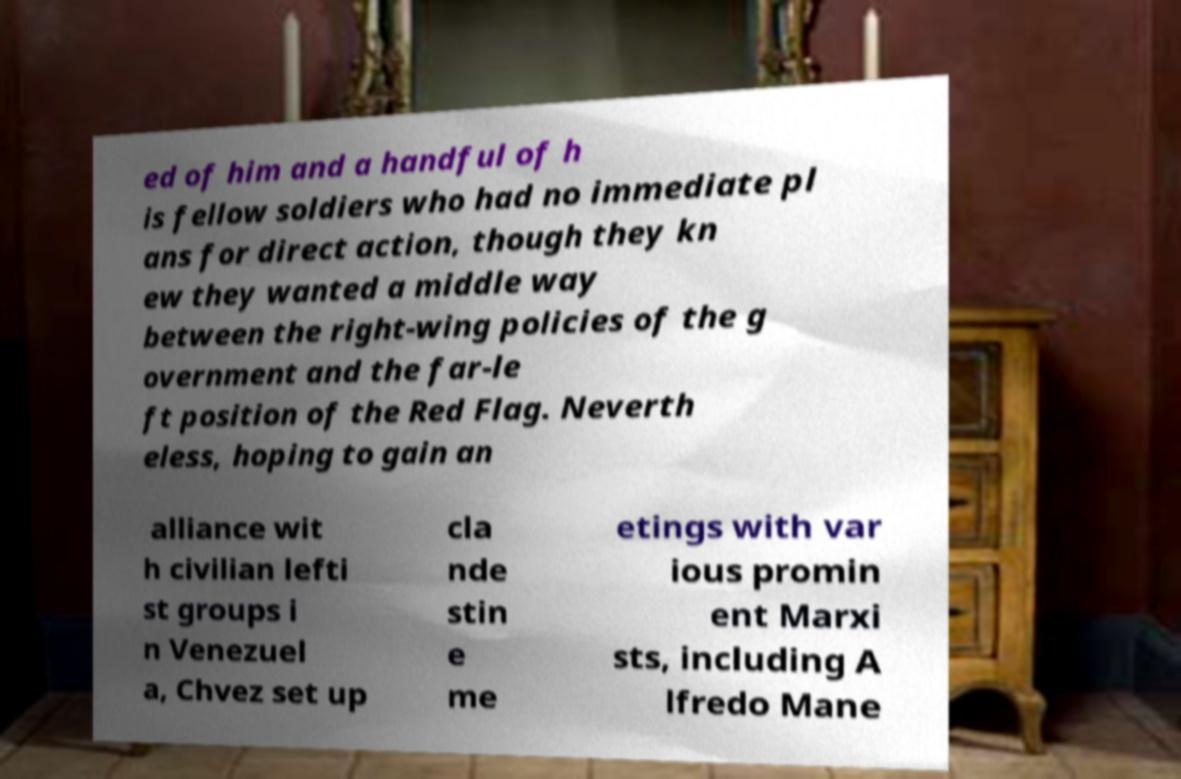What messages or text are displayed in this image? I need them in a readable, typed format. ed of him and a handful of h is fellow soldiers who had no immediate pl ans for direct action, though they kn ew they wanted a middle way between the right-wing policies of the g overnment and the far-le ft position of the Red Flag. Neverth eless, hoping to gain an alliance wit h civilian lefti st groups i n Venezuel a, Chvez set up cla nde stin e me etings with var ious promin ent Marxi sts, including A lfredo Mane 